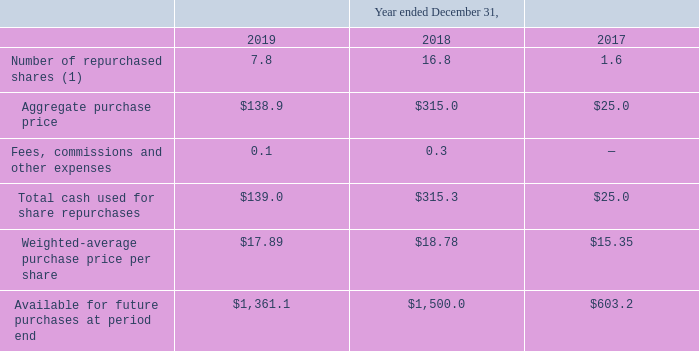Share Repurchase Programs
On December 1, 2014, the Company announced the "Capital Allocation Policy" under which the Company intends to return to stockholders approximately 80 percent of free cash flow, less repayments of long-term debt, subject to a variety of factors, including the strategic plans, market and economic conditions and the discretion of the Company’s board of directors. For the purposes of the Capital Allocation Policy, the Company defines "free cash flow" as net cash provided by operating activities less purchases of property, plant and equipment.
On December 1, 2014, the Company announced the 2014 Share Repurchase Program (the "2014 Share Repurchase Program") pursuant to the Capital Allocation Policy. Under the Company’s 2014 Share Repurchase Program, the Company had the ability to repurchase up to $ 1.0 billion (exclusive of fees, commissions and other expenses) of the Company’s common stock over a period of four years from December 1, 2014, subject to certain contingencies.
The 2014 Share Repurchase Program, which did not require the Company to purchase any particular amount of common stock and was subject to the discretion of the board of directors, expired on November 30, 2018 with approximately $288.2 million remaining unutilized.
The Company repurchased common stock worth approximately $315.0 million and $25.0 million under the 2014 Share Repurchase Program during the years ended December 31, 2018 and December 31, 2017, respectively.
On November 15, 2018, the Company announced the 2018 Share Repurchase Program (the "2018 Share Repurchase Program") pursuant to the Capital Allocation Policy. Under the 2018 Share Repurchase Program, the Company is authorized to repurchase up to $ 1.5 billion of its common shares from December 1, 2018 through December 31, 2022, exclusive of any fees, commissions or other expenses.
The Company may repurchase its common stock from time to time in privately negotiated transactions or open market transactions, including pursuant to a trading plan in accordance with Rule 10b5-1 and Rule 10b-18 of the Exchange Act, or by any combination of such methods or other methods.
The timing of any repurchases and the actual number of shares repurchased will depend on a variety of factors, including the Company’s stock price, corporate and regulatory requirements, restrictions under the Company’s debt obligations and other market and economic conditions. There were $138.9 million in repurchases of the Company's common stock under the 2018 Share Repurchase Program during the year ended December 31, 2019. As of December 31, 2019, the remaining authorized amount under the 2018 Share Repurchase Program was $1,361.1 million.
Information relating to the Company's 2018 and 2014 Share Repurchase Programs is as follows (in millions, except per share data):
(1) None of these shares had been reissued or retired as of December 31, 2019, but may be reissued or retired by the Company at a later date.
When was "Capital Allocation Policy" announced? December 1, 2014. How is "free cash flow" defined for the the purposes of the Capital Allocation Policy? Net cash provided by operating activities less purchases of property, plant and equipment. What is the aggregate purchase price in 2019?
Answer scale should be: million. $138.9. What is the change in Number of repurchased shares from December 31, 2018 to 2019?
Answer scale should be: million. 7.8-16.8
Answer: -9. What is the change in Aggregate purchase price from year ended December 31, 2018 to 2019?
Answer scale should be: million. 138.9-315.0
Answer: -176.1. What is the average Number of repurchased shares for December 31, 2018 to 2019?
Answer scale should be: million. (7.8+16.8) / 2
Answer: 12.3. 